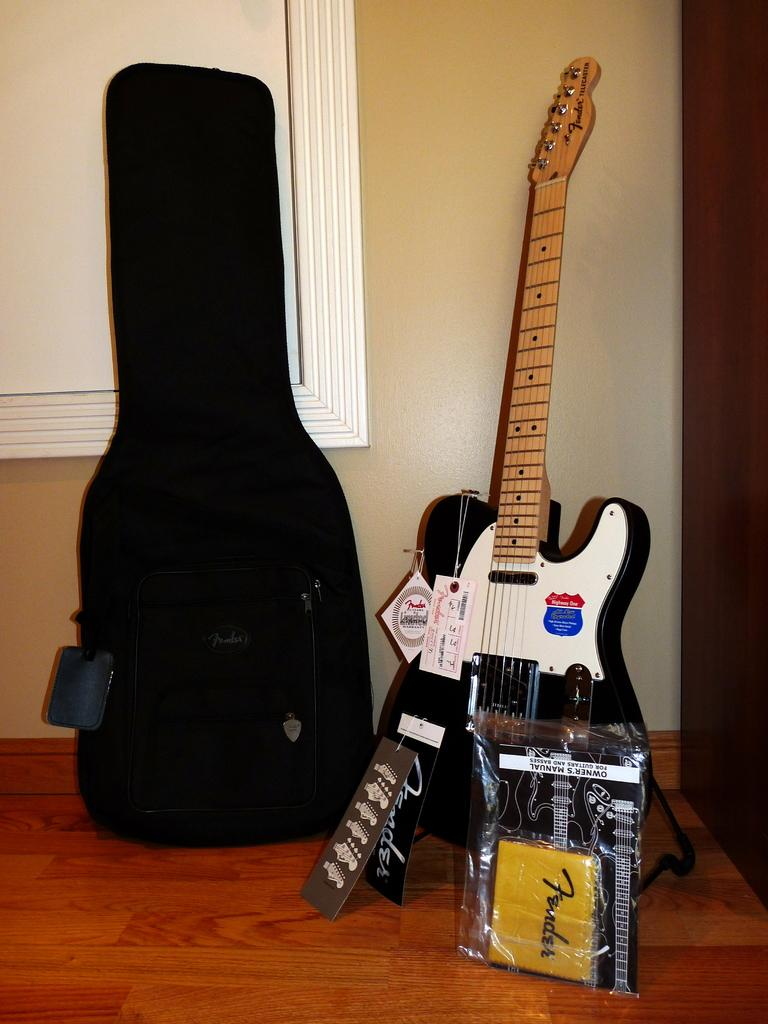What musical instrument is present in the image? There is a guitar in the image. How is the guitar positioned in the image? The guitar is placed on the floor. What other object is near the guitar? There is a backpack beside the guitar. Are there any additional details on the guitar? Yes, there are labels attached to the guitar. What type of crack is visible on the guitar's neck in the image? There is no crack visible on the guitar's neck in the image. How does the toothbrush help maintain the guitar in the image? There is no toothbrush present in the image, so it cannot help maintain the guitar. 